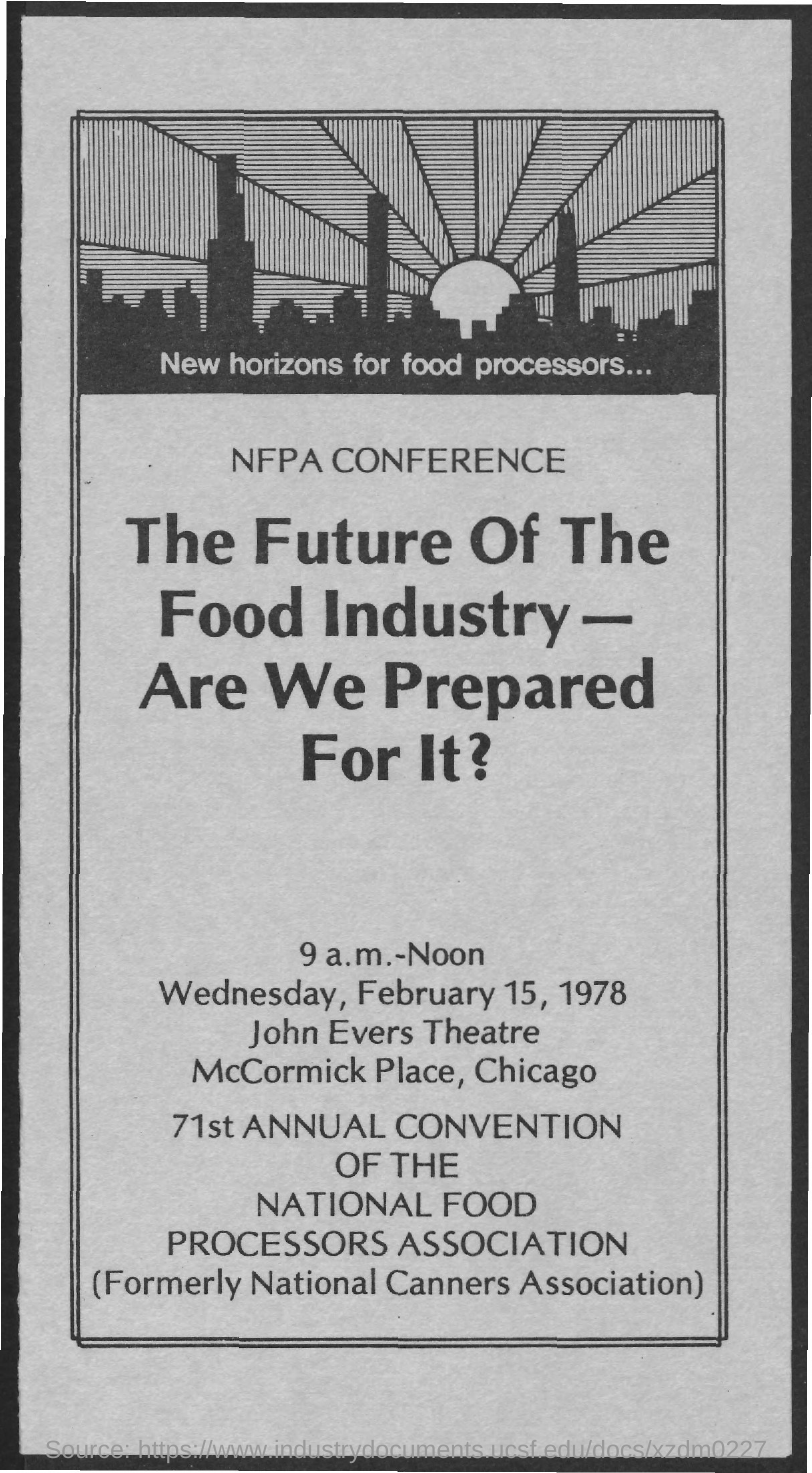What is the date mentioned ?
Make the answer very short. February 15, 1978. What is the name of the theatre
Your answer should be compact. John Evers. 